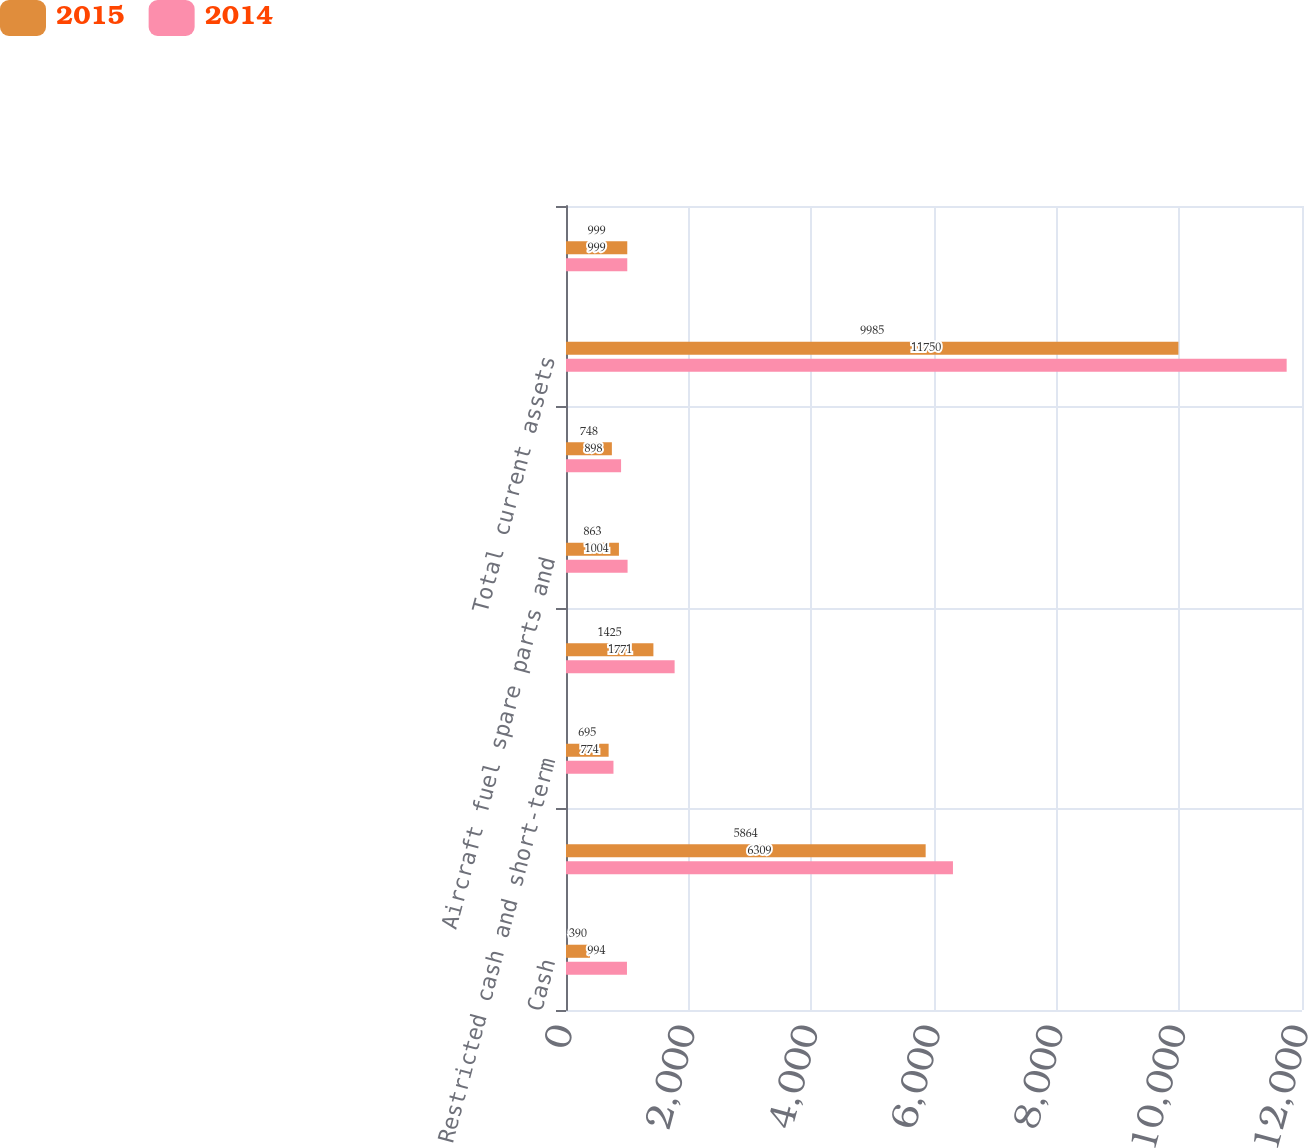Convert chart to OTSL. <chart><loc_0><loc_0><loc_500><loc_500><stacked_bar_chart><ecel><fcel>Cash<fcel>Short-term investments<fcel>Restricted cash and short-term<fcel>Accounts receivable net<fcel>Aircraft fuel spare parts and<fcel>Prepaid expenses and other<fcel>Total current assets<fcel>Flight equipment<nl><fcel>2015<fcel>390<fcel>5864<fcel>695<fcel>1425<fcel>863<fcel>748<fcel>9985<fcel>999<nl><fcel>2014<fcel>994<fcel>6309<fcel>774<fcel>1771<fcel>1004<fcel>898<fcel>11750<fcel>999<nl></chart> 